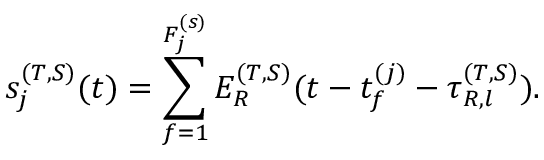Convert formula to latex. <formula><loc_0><loc_0><loc_500><loc_500>s _ { j } ^ { ( T , S ) } ( t ) = \sum _ { f = 1 } ^ { F _ { j } ^ { ( s ) } } E _ { R } ^ { ( T , S ) } ( t - t _ { f } ^ { ( j ) } - \tau _ { R , l } ^ { ( T , S ) } ) .</formula> 